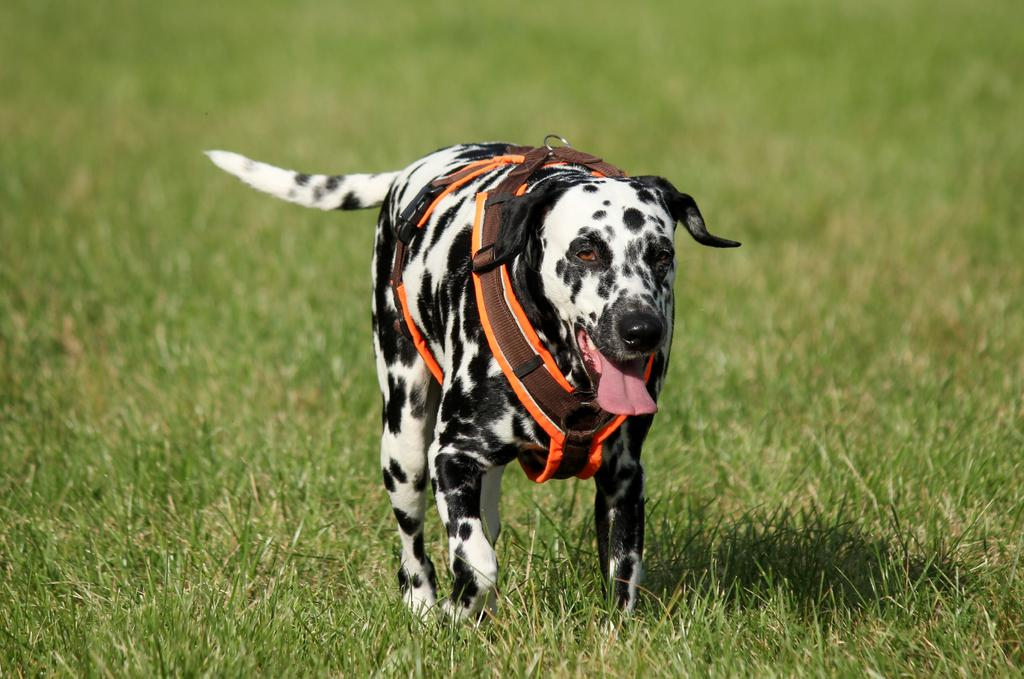What is the main subject in the center of the image? There is a dog in the center of the image. What type of surface is visible at the bottom of the image? There is grass at the bottom of the image. What is the dog's opinion on the whip in the image? There is no whip present in the image, so the dog's opinion cannot be determined. How many sheep are visible in the image? There are no sheep present in the image. 